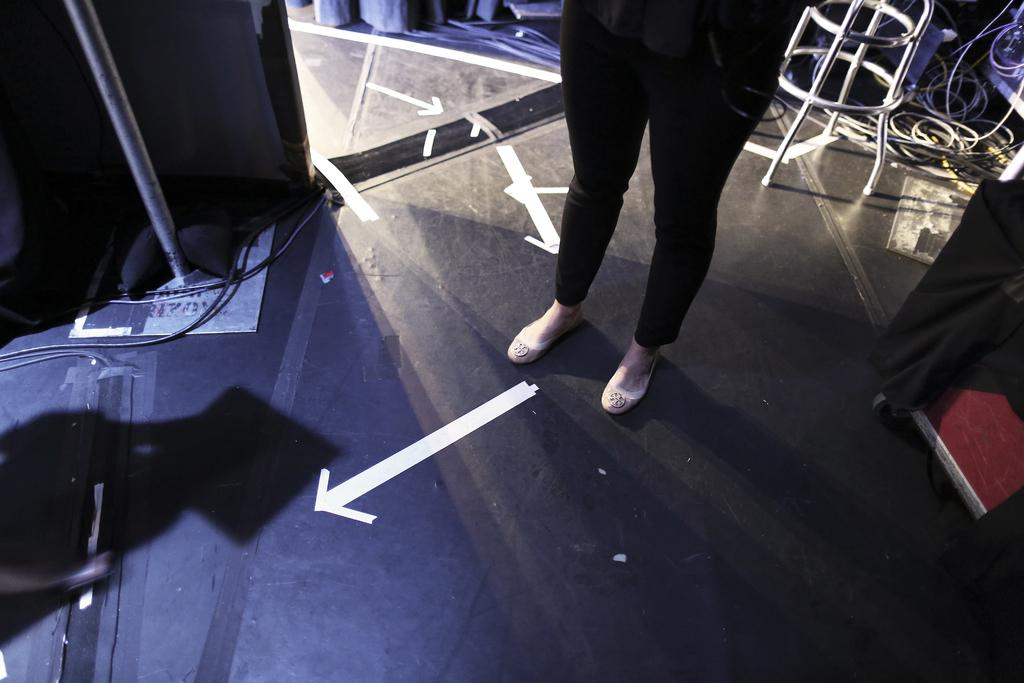What part of a person can be seen in the image? There are legs of a person in the image. What type of objects are present in the image that are related to electricity or technology? There are cables in the image. What type of window treatment is visible in the image? There are curtains in the image. What type of objects are present in the image that are used for supporting or holding other objects? There are stands in the image. Can you describe any other objects in the image that are not specified in the facts? Unfortunately, the provided facts do not give any details about other objects in the image. What type of advice can be seen being given in the image? There is no advice present in the image; it only shows legs of a person, cables, curtains, and stands. Can you tell me what type of humor is being displayed in the image? There is no humor present in the image; it only shows legs of a person, cables, curtains, and stands. 